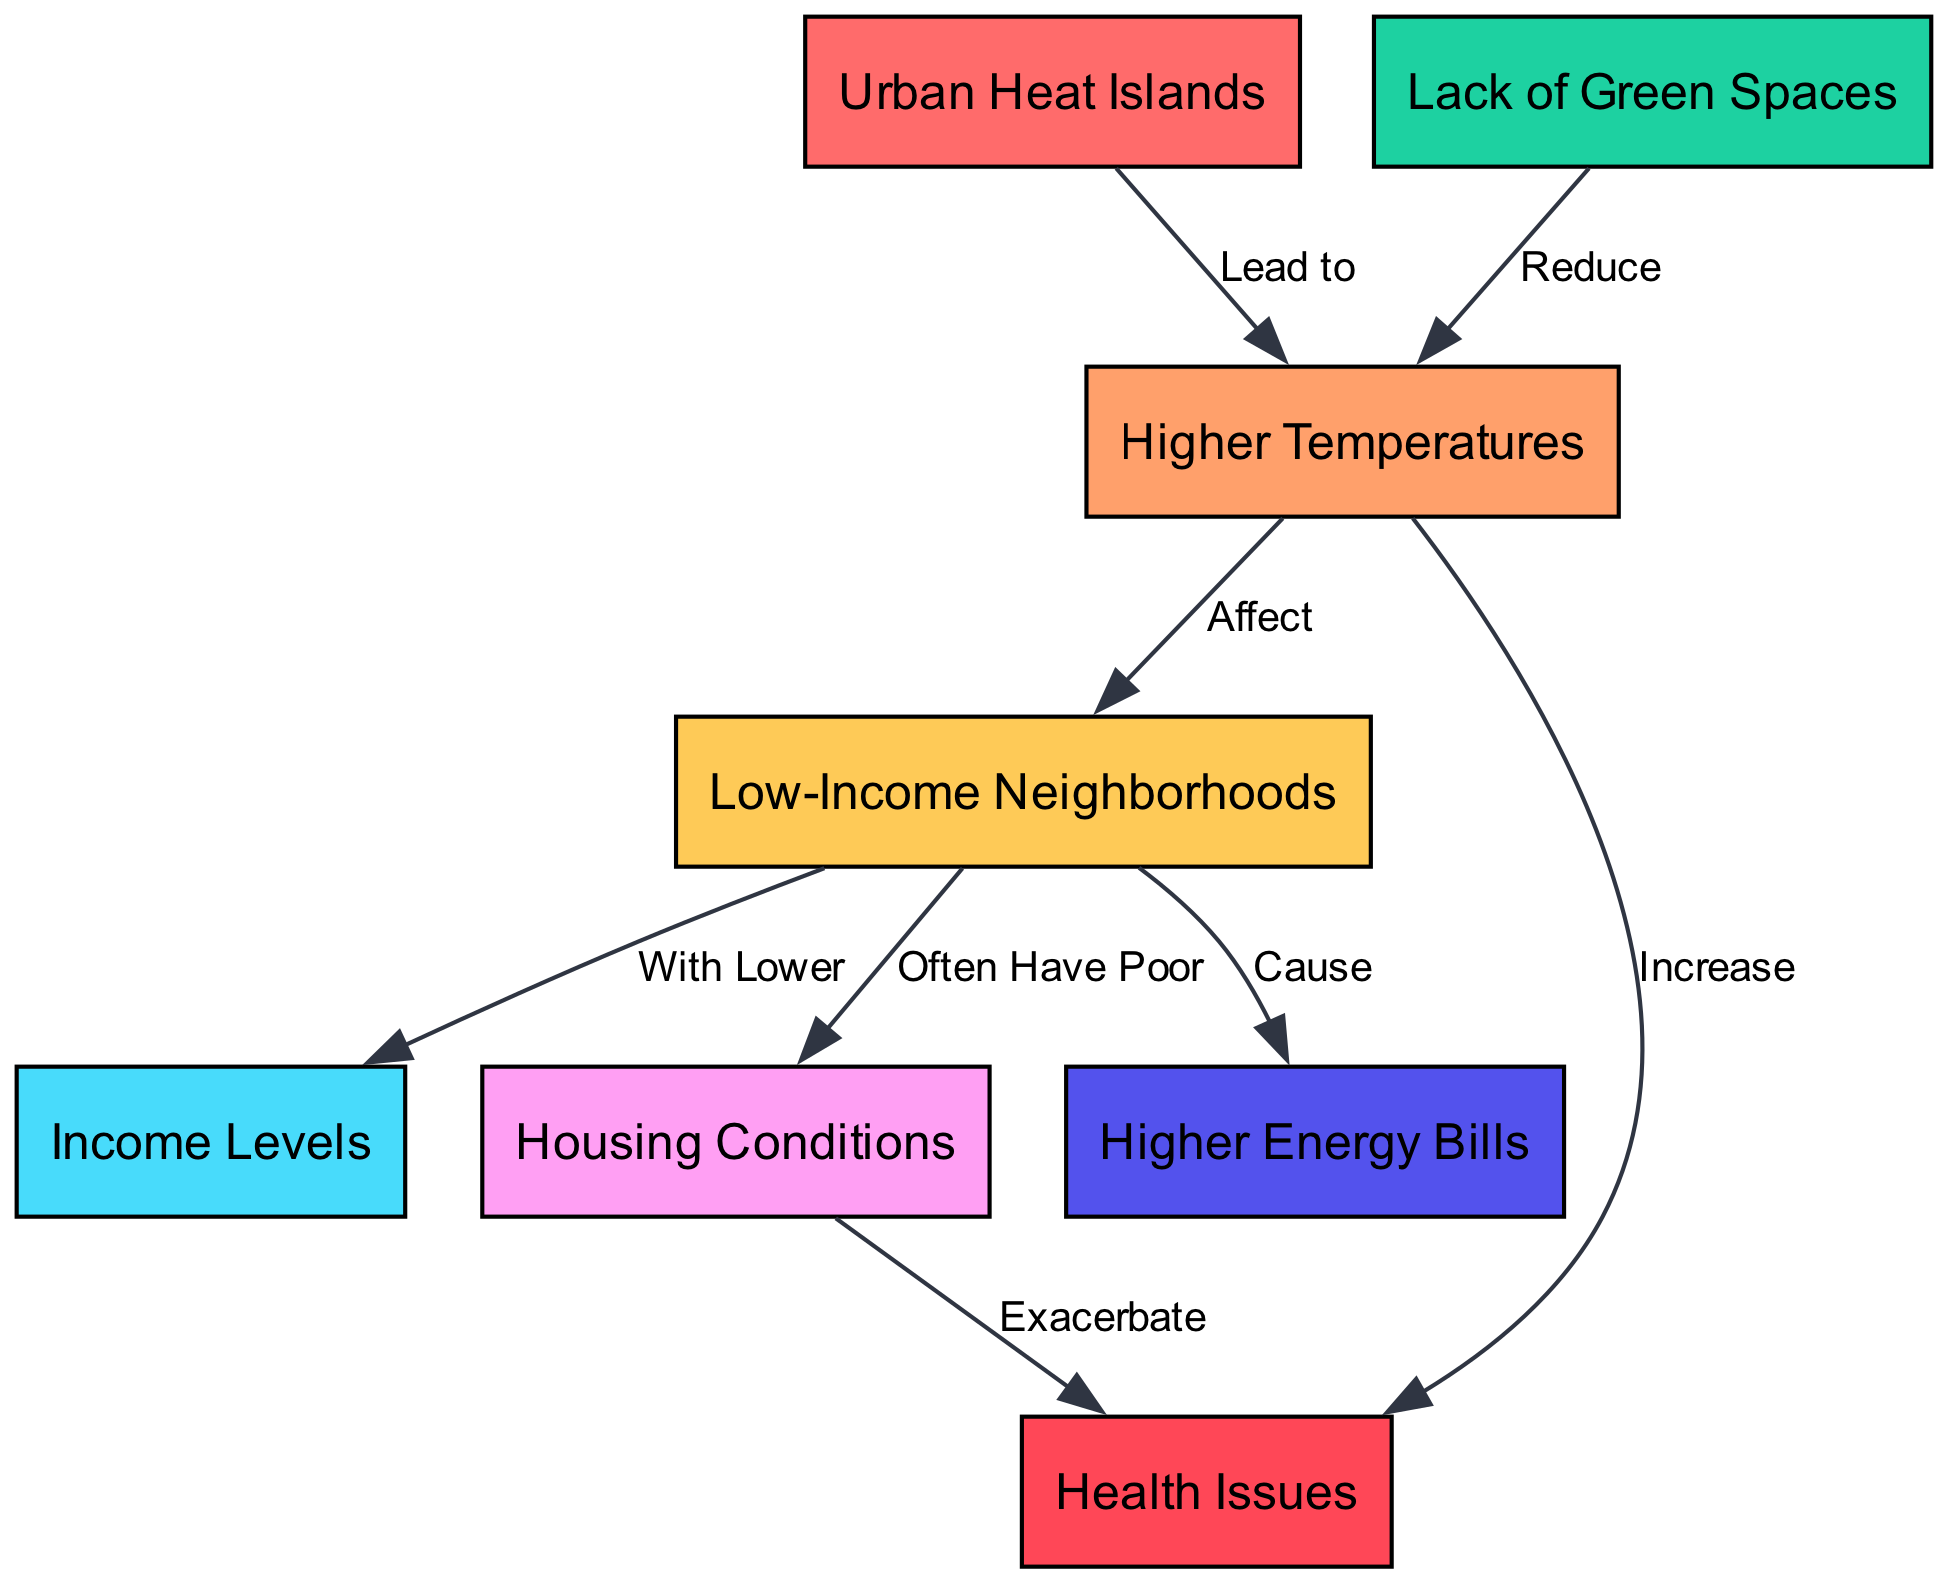What is the central cause of higher temperatures in urban areas? The diagram indicates that "Urban Heat Islands" are the central cause of "Higher Temperatures," showing a direct connection between these two nodes.
Answer: Urban Heat Islands How do higher temperatures affect low-income neighborhoods? According to the diagram, "Higher Temperatures" directly "Affect" "Low-Income Neighborhoods," suggesting a negative impact on these areas due to increased heat.
Answer: Affect What is indicated as a consequence of low-income neighborhoods having lower income levels? The diagram states that "Low-Income Neighborhoods" "With Lower" "Income Levels," indicates that low-income neighborhoods typically experience financial challenges.
Answer: Lower How often do low-income neighborhoods have poor housing conditions? The diagram shows a direct link between "Low-Income Neighborhoods" and "Often Have Poor" "Housing Conditions," suggesting that poor housing conditions are common in these areas.
Answer: Often Have Poor What health issues are exacerbated in low-income neighborhoods? The diagram connects "Housing Conditions" to "Health Issues," indicating that poor housing conditions contribute to an increase in health issues experienced by residents.
Answer: Health Issues Which factor is noted as reducing higher temperatures? "Green Spaces" in the diagram are shown to "Reduce" "High Temps," highlighting the importance of green areas in cooling urban environments.
Answer: Reduce What is affected by higher temperatures according to the diagram? The diagram shows that "High Temps" "Increase" "Health Issues," which suggests that higher temperatures can lead to more health problems for residents.
Answer: Health Issues What do low-income neighborhoods cause in relation to energy bills? The diagram states that "Low-Income Neighborhoods" "Cause" "Higher Energy Bills," implying that residents in these areas face increased energy costs, likely due to heat.
Answer: Higher Energy Bills How do the housing conditions impact health? The diagram indicates that "Housing Conditions" "Exacerbate" "Health Issues," revealing a critical relationship between the state of housing and resident health outcomes.
Answer: Exacerbate 